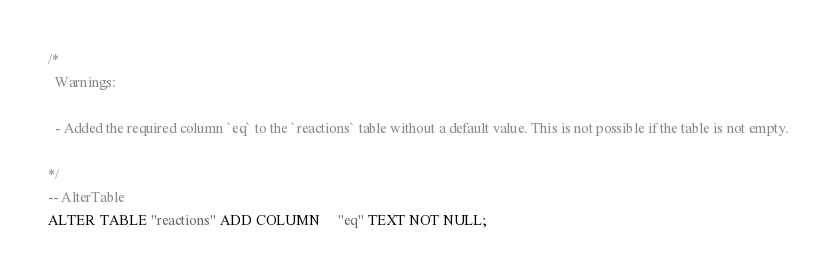<code> <loc_0><loc_0><loc_500><loc_500><_SQL_>/*
  Warnings:

  - Added the required column `eq` to the `reactions` table without a default value. This is not possible if the table is not empty.

*/
-- AlterTable
ALTER TABLE "reactions" ADD COLUMN     "eq" TEXT NOT NULL;
</code> 